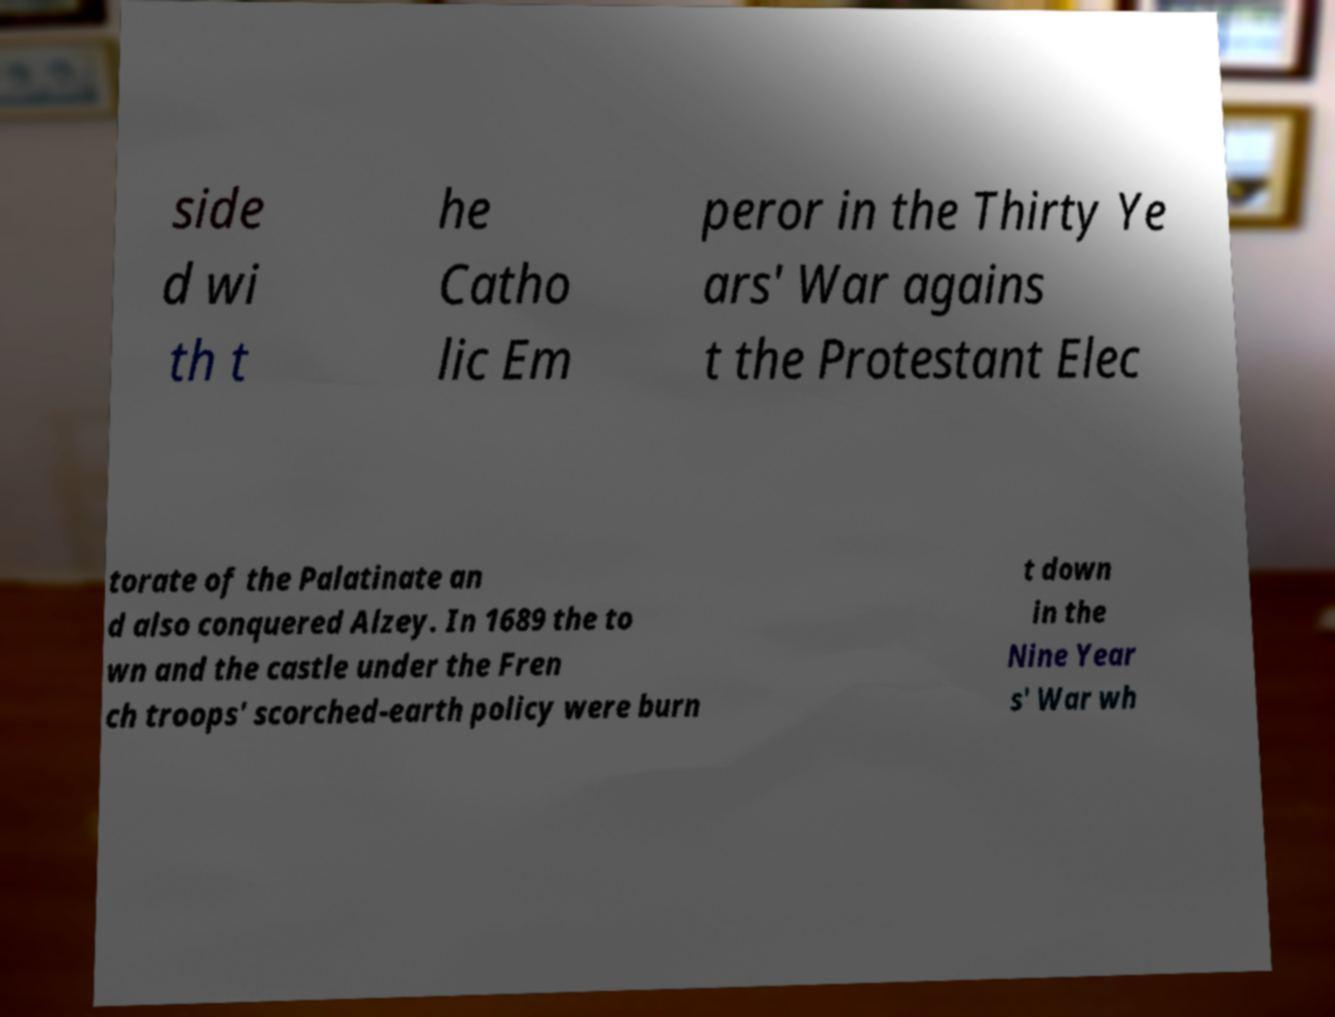What messages or text are displayed in this image? I need them in a readable, typed format. side d wi th t he Catho lic Em peror in the Thirty Ye ars' War agains t the Protestant Elec torate of the Palatinate an d also conquered Alzey. In 1689 the to wn and the castle under the Fren ch troops' scorched-earth policy were burn t down in the Nine Year s' War wh 